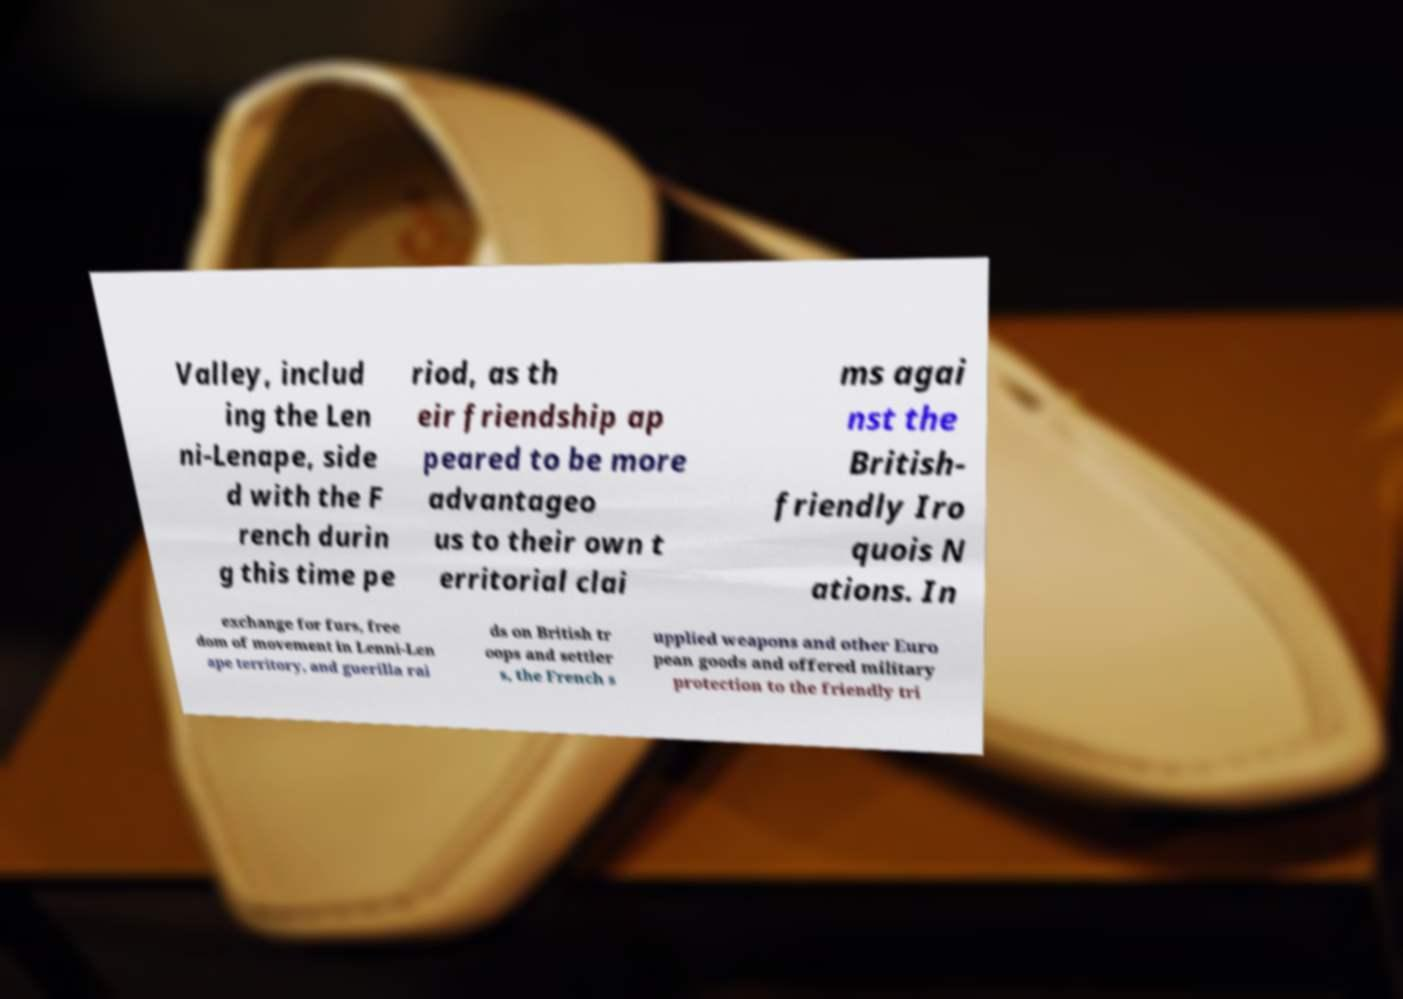I need the written content from this picture converted into text. Can you do that? Valley, includ ing the Len ni-Lenape, side d with the F rench durin g this time pe riod, as th eir friendship ap peared to be more advantageo us to their own t erritorial clai ms agai nst the British- friendly Iro quois N ations. In exchange for furs, free dom of movement in Lenni-Len ape territory, and guerilla rai ds on British tr oops and settler s, the French s upplied weapons and other Euro pean goods and offered military protection to the friendly tri 